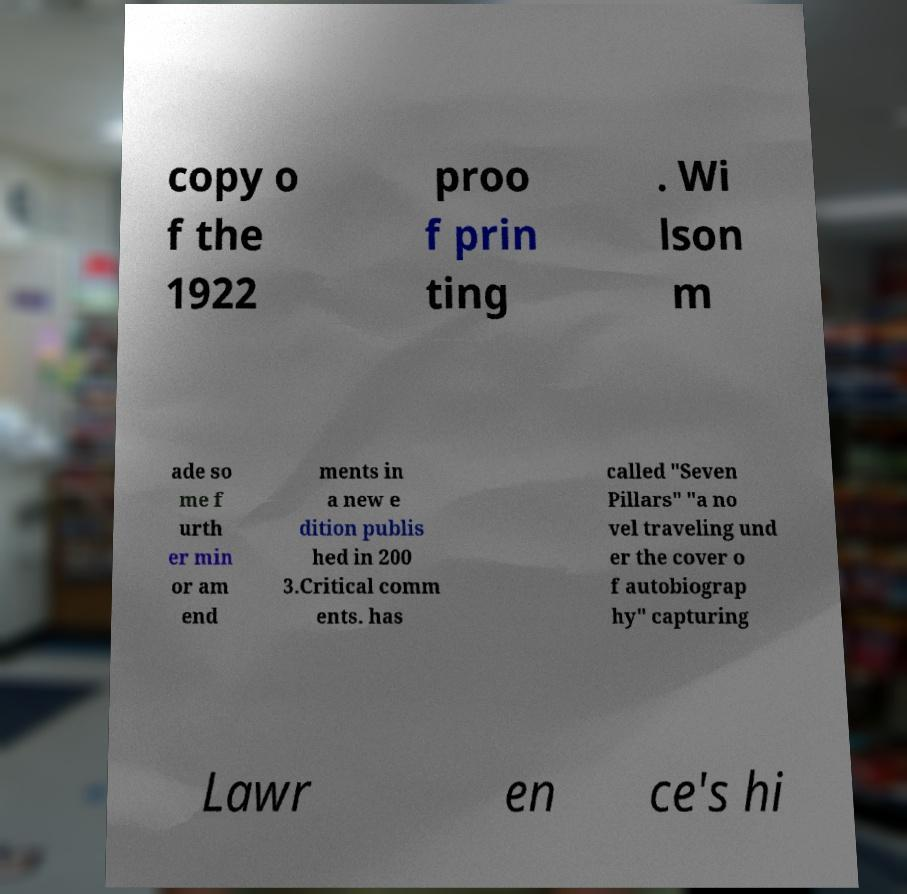Can you accurately transcribe the text from the provided image for me? copy o f the 1922 proo f prin ting . Wi lson m ade so me f urth er min or am end ments in a new e dition publis hed in 200 3.Critical comm ents. has called "Seven Pillars" "a no vel traveling und er the cover o f autobiograp hy" capturing Lawr en ce's hi 